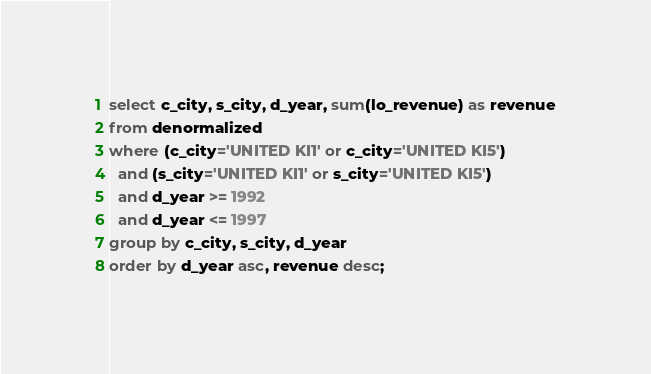<code> <loc_0><loc_0><loc_500><loc_500><_SQL_>select c_city, s_city, d_year, sum(lo_revenue) as revenue
from denormalized
where (c_city='UNITED KI1' or c_city='UNITED KI5')
  and (s_city='UNITED KI1' or s_city='UNITED KI5')
  and d_year >= 1992
  and d_year <= 1997
group by c_city, s_city, d_year
order by d_year asc, revenue desc;
</code> 